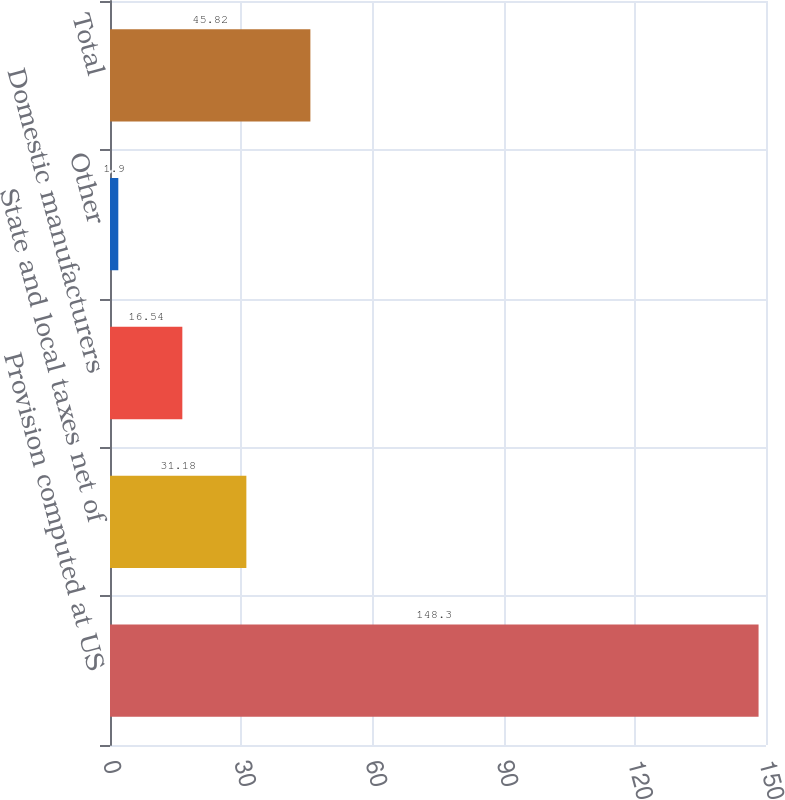Convert chart. <chart><loc_0><loc_0><loc_500><loc_500><bar_chart><fcel>Provision computed at US<fcel>State and local taxes net of<fcel>Domestic manufacturers<fcel>Other<fcel>Total<nl><fcel>148.3<fcel>31.18<fcel>16.54<fcel>1.9<fcel>45.82<nl></chart> 